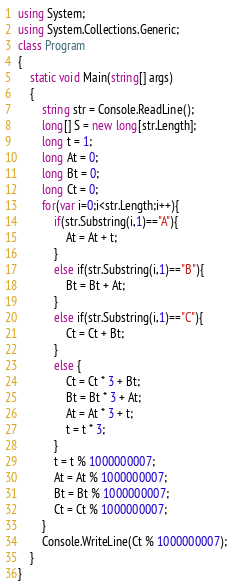Convert code to text. <code><loc_0><loc_0><loc_500><loc_500><_C#_>using System;
using System.Collections.Generic;
class Program
{
	static void Main(string[] args)
	{
		string str = Console.ReadLine();
		long[] S = new long[str.Length];
		long t = 1;
		long At = 0;
		long Bt = 0;
		long Ct = 0;
		for(var i=0;i<str.Length;i++){
			if(str.Substring(i,1)=="A"){
				At = At + t;
			}
			else if(str.Substring(i,1)=="B"){
				Bt = Bt + At;
			}
			else if(str.Substring(i,1)=="C"){
				Ct = Ct + Bt;
			}
			else {
				Ct = Ct * 3 + Bt;
				Bt = Bt * 3 + At;
				At = At * 3 + t;
				t = t * 3;
			}
			t = t % 1000000007;
			At = At % 1000000007;
			Bt = Bt % 1000000007;
			Ct = Ct % 1000000007;
		}
		Console.WriteLine(Ct % 1000000007);
	}
}</code> 